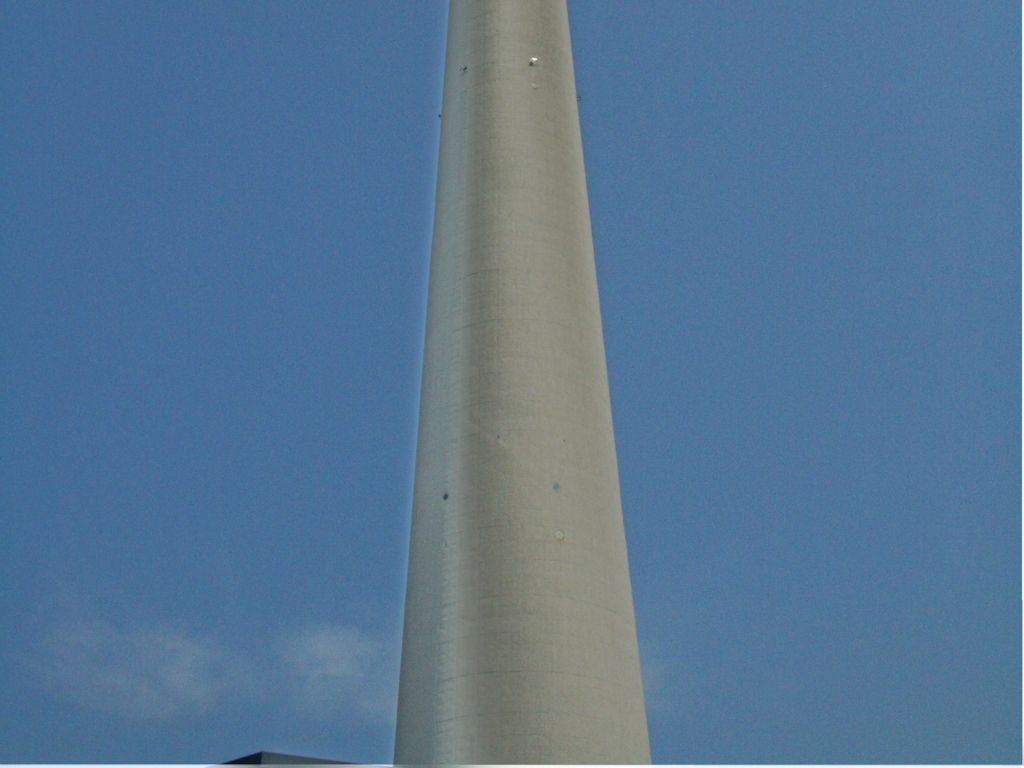Given the limited view, can we infer its height or the materials used in its construction? Even with the limited view, the smooth texture and uniform color suggest it's made of concrete or a similar composite material. The perspective indicates considerable height, but without reference points like buildings or people, the precise height remains uncertain. 